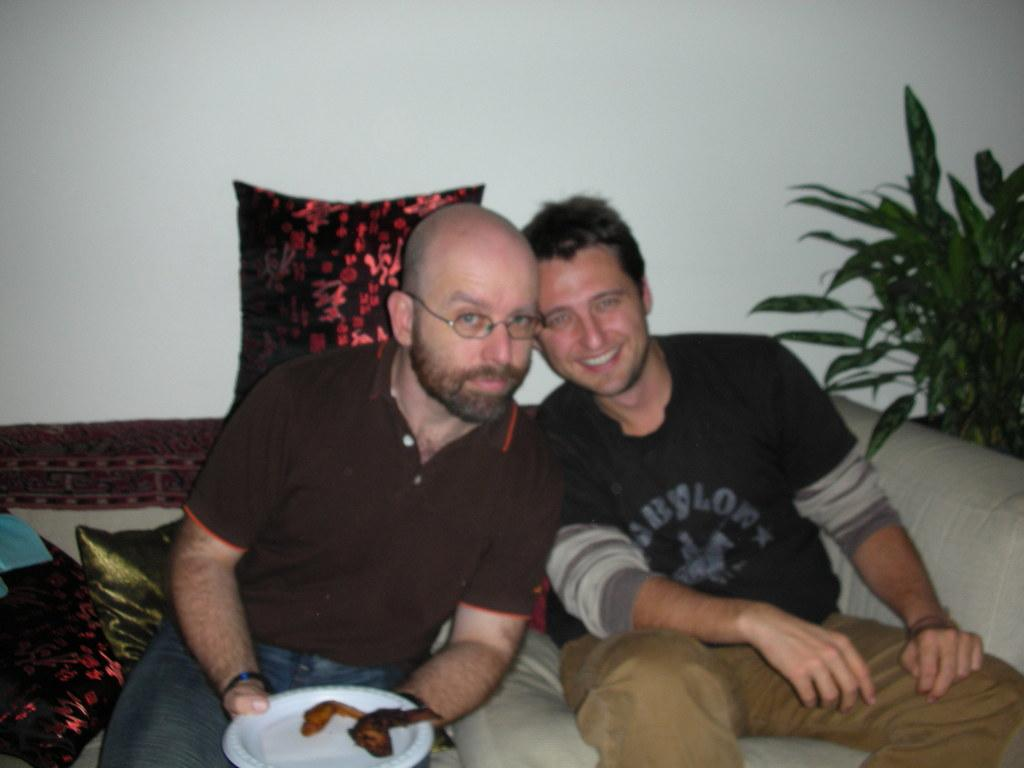How many people are in the image? There are two men in the image. What are the men doing in the image? The men are sitting on a sofa. What is one of the men holding in the image? One man is holding a plate with food. What can be seen in the background of the image? There is a wall and plants in the background of the image. What type of furniture is present in the image? There are pillows in the image. Can you see any horses in the image? No, there are no horses present in the image. What type of locket is the man wearing in the image? There is no locket visible on either man in the image. 